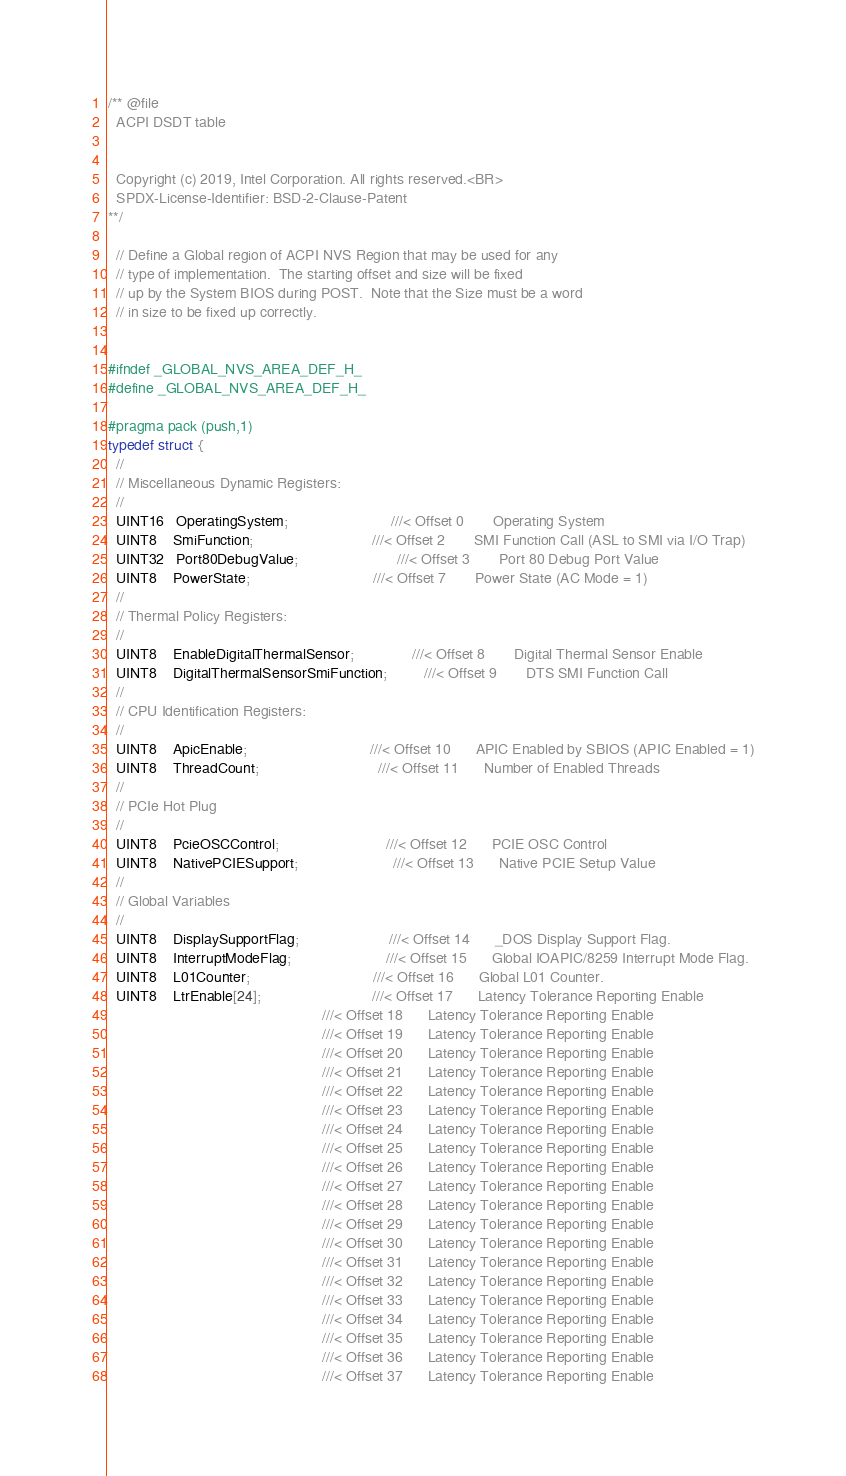Convert code to text. <code><loc_0><loc_0><loc_500><loc_500><_C_>/** @file
  ACPI DSDT table


  Copyright (c) 2019, Intel Corporation. All rights reserved.<BR>
  SPDX-License-Identifier: BSD-2-Clause-Patent
**/

  // Define a Global region of ACPI NVS Region that may be used for any
  // type of implementation.  The starting offset and size will be fixed
  // up by the System BIOS during POST.  Note that the Size must be a word
  // in size to be fixed up correctly.


#ifndef _GLOBAL_NVS_AREA_DEF_H_
#define _GLOBAL_NVS_AREA_DEF_H_

#pragma pack (push,1)
typedef struct {
  //
  // Miscellaneous Dynamic Registers:
  //
  UINT16   OperatingSystem;                         ///< Offset 0       Operating System
  UINT8    SmiFunction;                             ///< Offset 2       SMI Function Call (ASL to SMI via I/O Trap)
  UINT32   Port80DebugValue;                        ///< Offset 3       Port 80 Debug Port Value
  UINT8    PowerState;                              ///< Offset 7       Power State (AC Mode = 1)
  //
  // Thermal Policy Registers:
  //
  UINT8    EnableDigitalThermalSensor;              ///< Offset 8       Digital Thermal Sensor Enable
  UINT8    DigitalThermalSensorSmiFunction;         ///< Offset 9       DTS SMI Function Call
  //
  // CPU Identification Registers:
  //
  UINT8    ApicEnable;                              ///< Offset 10      APIC Enabled by SBIOS (APIC Enabled = 1)
  UINT8    ThreadCount;                             ///< Offset 11      Number of Enabled Threads
  //
  // PCIe Hot Plug
  //
  UINT8    PcieOSCControl;                          ///< Offset 12      PCIE OSC Control
  UINT8    NativePCIESupport;                       ///< Offset 13      Native PCIE Setup Value
  //
  // Global Variables
  //
  UINT8    DisplaySupportFlag;                      ///< Offset 14      _DOS Display Support Flag.
  UINT8    InterruptModeFlag;                       ///< Offset 15      Global IOAPIC/8259 Interrupt Mode Flag.
  UINT8    L01Counter;                              ///< Offset 16      Global L01 Counter.
  UINT8    LtrEnable[24];                           ///< Offset 17      Latency Tolerance Reporting Enable
                                                    ///< Offset 18      Latency Tolerance Reporting Enable
                                                    ///< Offset 19      Latency Tolerance Reporting Enable
                                                    ///< Offset 20      Latency Tolerance Reporting Enable
                                                    ///< Offset 21      Latency Tolerance Reporting Enable
                                                    ///< Offset 22      Latency Tolerance Reporting Enable
                                                    ///< Offset 23      Latency Tolerance Reporting Enable
                                                    ///< Offset 24      Latency Tolerance Reporting Enable
                                                    ///< Offset 25      Latency Tolerance Reporting Enable
                                                    ///< Offset 26      Latency Tolerance Reporting Enable
                                                    ///< Offset 27      Latency Tolerance Reporting Enable
                                                    ///< Offset 28      Latency Tolerance Reporting Enable
                                                    ///< Offset 29      Latency Tolerance Reporting Enable
                                                    ///< Offset 30      Latency Tolerance Reporting Enable
                                                    ///< Offset 31      Latency Tolerance Reporting Enable
                                                    ///< Offset 32      Latency Tolerance Reporting Enable
                                                    ///< Offset 33      Latency Tolerance Reporting Enable
                                                    ///< Offset 34      Latency Tolerance Reporting Enable
                                                    ///< Offset 35      Latency Tolerance Reporting Enable
                                                    ///< Offset 36      Latency Tolerance Reporting Enable
                                                    ///< Offset 37      Latency Tolerance Reporting Enable</code> 